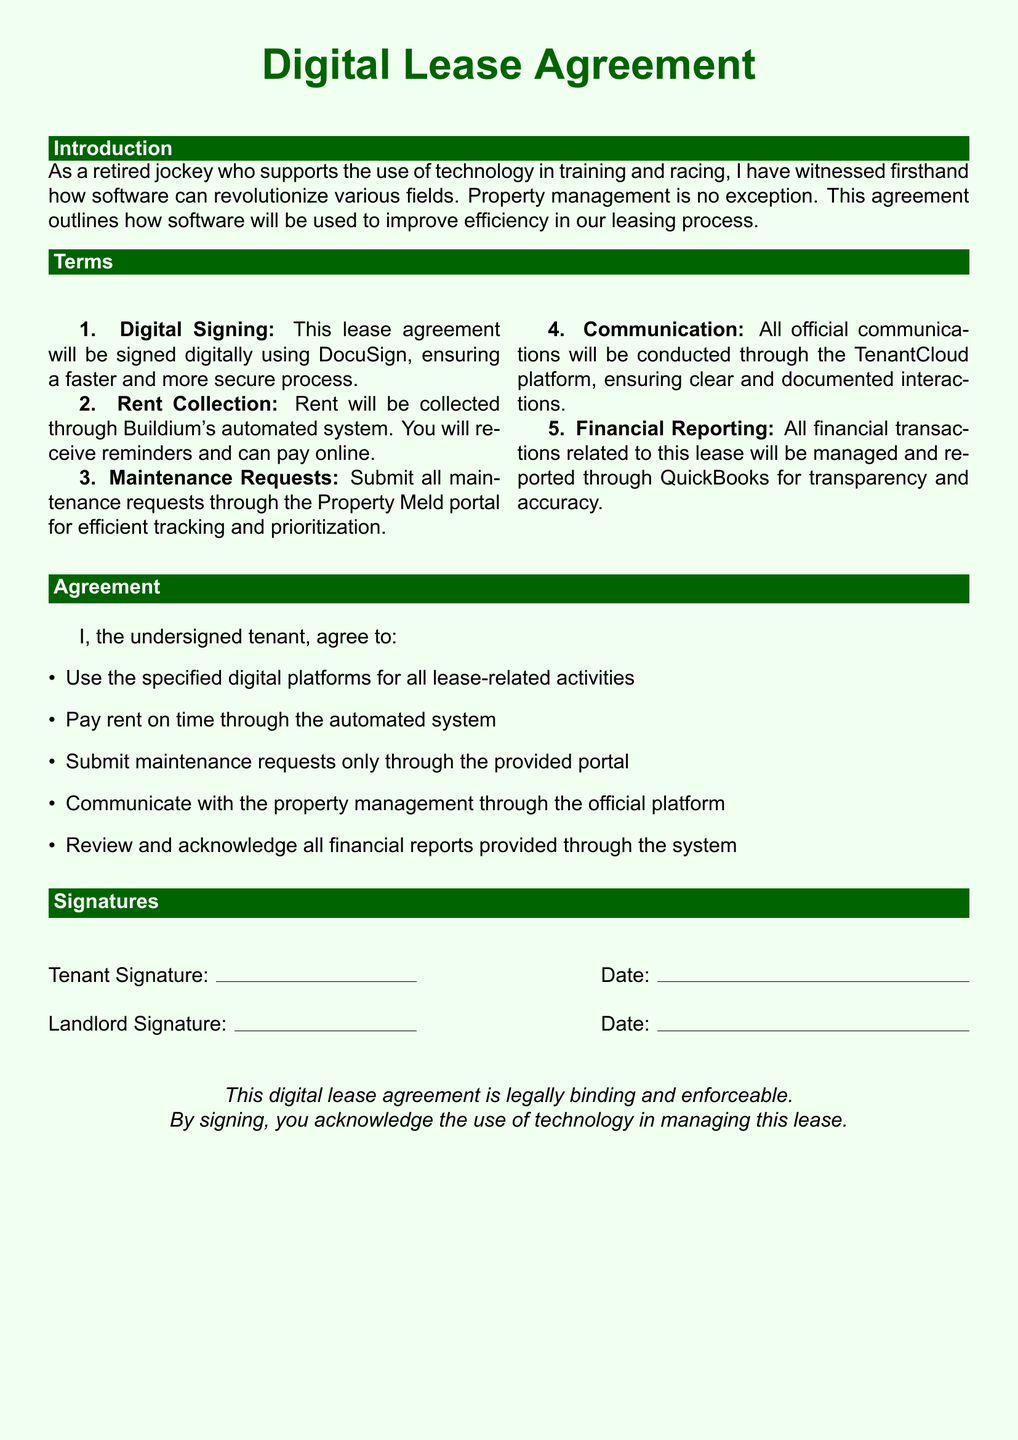What is the electronic method for signing the lease agreement? The lease agreement will be signed digitally using DocuSign, which is mentioned in the terms section.
Answer: DocuSign What platform is used for rent collection? Rent will be collected through Buildium's automated system, as stated in the terms section.
Answer: Buildium Where should maintenance requests be submitted? Maintenance requests need to be submitted through the Property Meld portal, according to the document.
Answer: Property Meld What will all official communications be conducted through? The document specifies that all official communications will occur through the TenantCloud platform.
Answer: TenantCloud Which software is used for financial reporting? QuickBooks is mentioned in the terms for managing and reporting financial transactions.
Answer: QuickBooks How many items must the tenant agree to in the agreement section? The agreement section contains five specific items that the tenant must agree to.
Answer: Five What does the document say about the legal nature of the lease agreement? It states that the digital lease agreement is legally binding and enforceable.
Answer: Legally binding What color is used for the background of the document? The document indicates that it has a light green background color.
Answer: Light green Who is required to sign the lease agreement? The document requires both the tenant and the landlord to sign the lease agreement.
Answer: Tenant and Landlord 